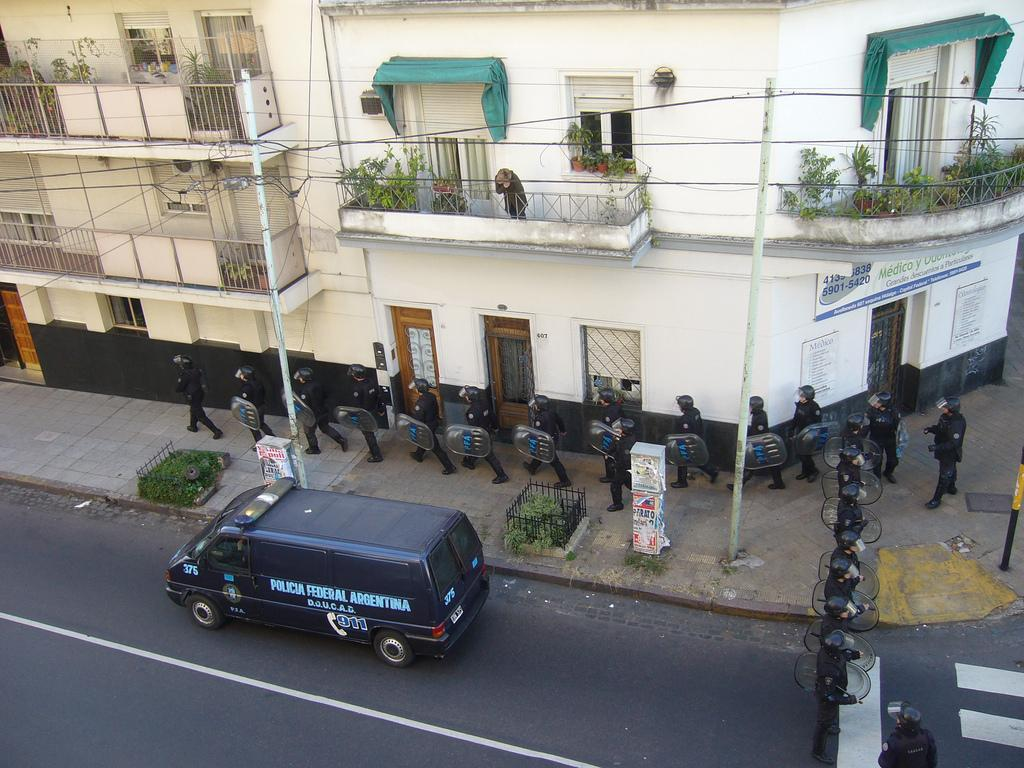What is the main feature of the image? There is a road in the image. What is on the road? There is a van on the road. Are there any people in the image? Yes, there are people visible in the image. What else can be seen in the background? There are buildings in the image. What type of powder is being used by the people in the image? There is no powder visible or mentioned in the image. 